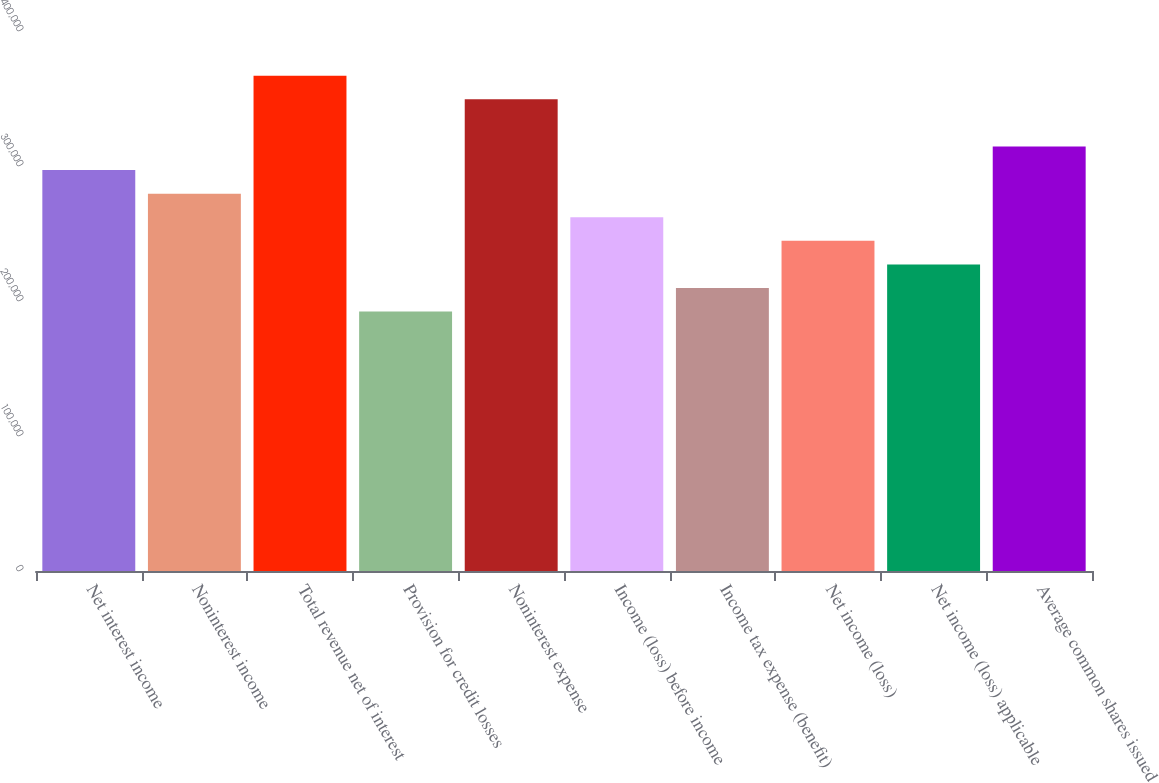Convert chart. <chart><loc_0><loc_0><loc_500><loc_500><bar_chart><fcel>Net interest income<fcel>Noninterest income<fcel>Total revenue net of interest<fcel>Provision for credit losses<fcel>Noninterest expense<fcel>Income (loss) before income<fcel>Income tax expense (benefit)<fcel>Net income (loss)<fcel>Net income (loss) applicable<fcel>Average common shares issued<nl><fcel>296990<fcel>279520<fcel>366870<fcel>192170<fcel>349400<fcel>262050<fcel>209640<fcel>244580<fcel>227110<fcel>314460<nl></chart> 